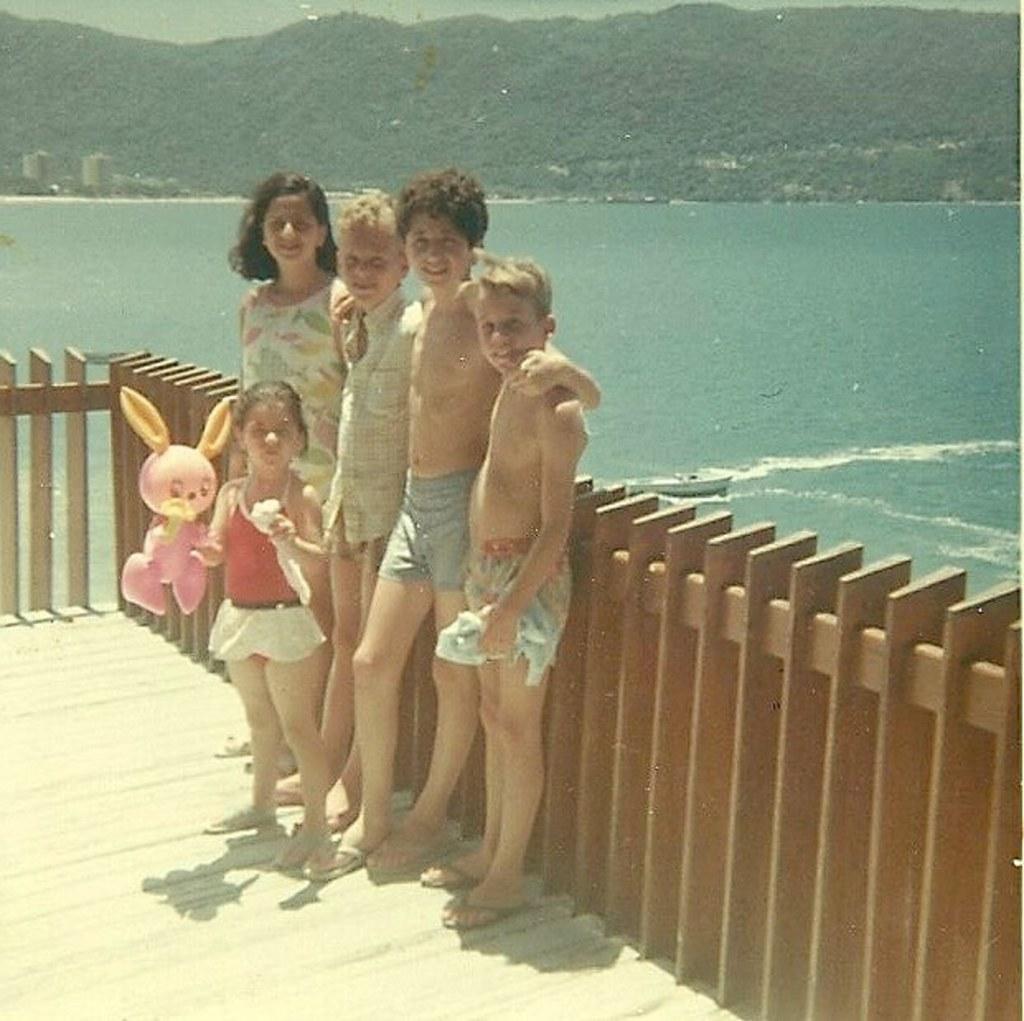How would you summarize this image in a sentence or two? This picture shows few boys and couple of girls standing and we see a girl holding a toy in her hand and we see a wooden fence and a boat in the water and we see trees. 